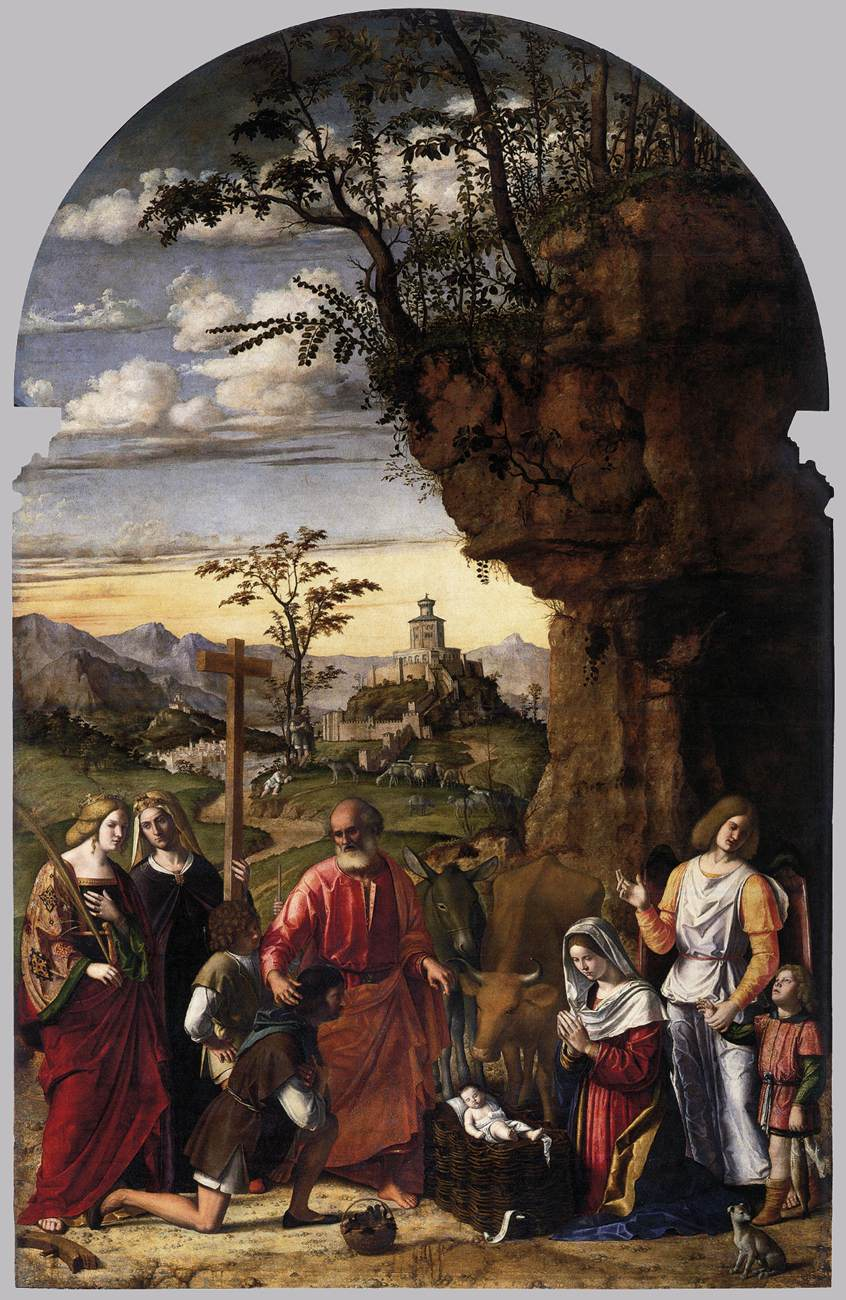What artistic techniques can be observed in this painting? This painting showcases several distinguished artistic techniques typical of the Renaissance period. The use of chiaroscuro, the contrast between light and dark, creates depth and dimensionality. The artist employs linear perspective, providing a realistic sense of space and distance. The meticulous attention to detail in the fabric of the clothing and the textures of the natural environment reflects a high level of skill. The harmonious color palette brings balance and unity to the composition, while the expressive faces convey the narrative's emotional weight. Can you explain the cultural context of this painting? Paintings such as this one were created during the Renaissance, a period of renewed interest in classical philosophy, literature, and art. Religious themes were prevalent as the Church was the primary patron of the arts. This painting, depicting the Adoration of the Christ Child, aligns with the era's emphasis on Biblical narratives, aiming to inspire devotion and piety. The detailed, realistic style reflects the period's humanistic focus on the natural world and the accurate depiction of human figures, emphasizing both spiritual and earthly beauty. 